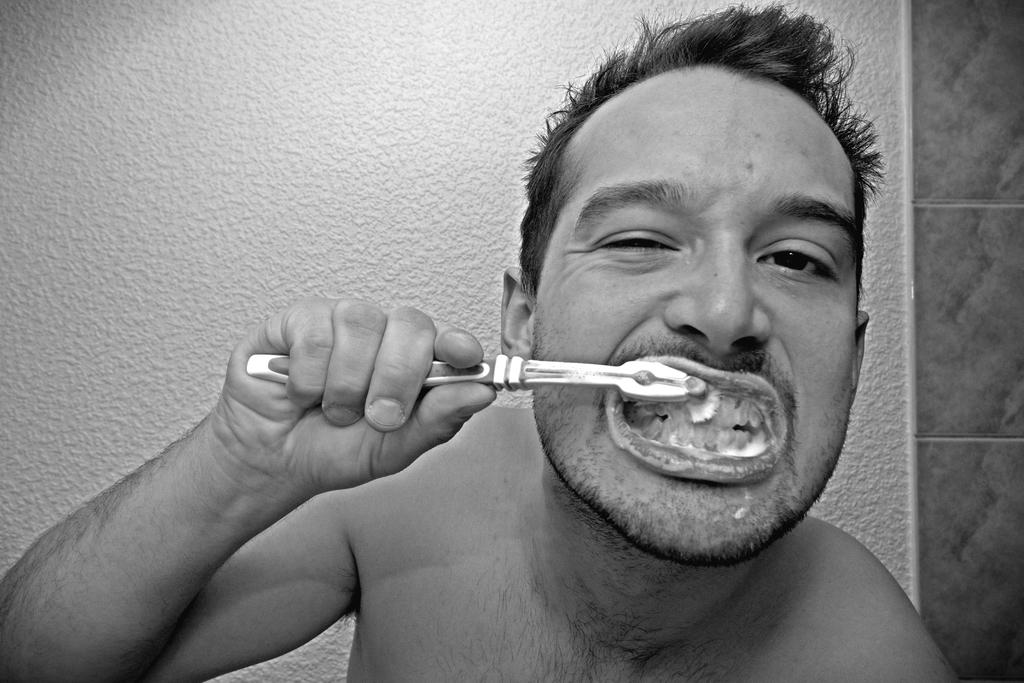What is the man in the image doing? The man is brushing his teeth. Can you describe the background of the image? There is a wall in the background of the image. What type of hammer is the man using while driving in the image? There is no hammer or driving depicted in the image; the man is brushing his teeth. 